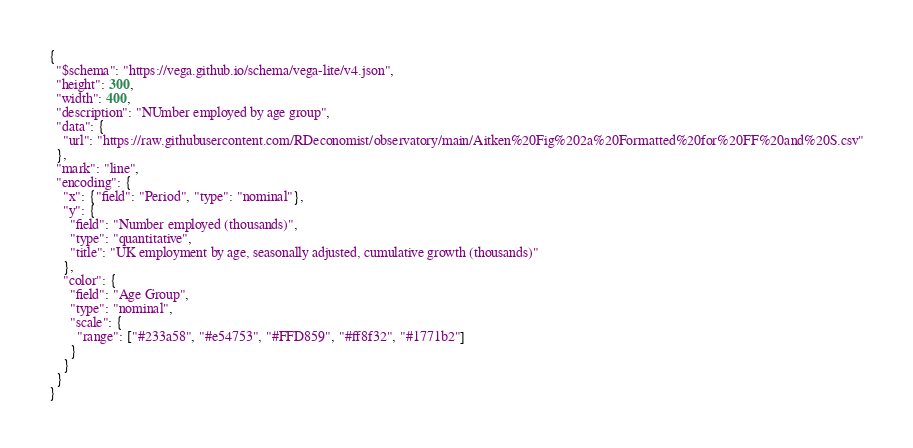<code> <loc_0><loc_0><loc_500><loc_500><_JavaScript_>{
  "$schema": "https://vega.github.io/schema/vega-lite/v4.json",
  "height": 300,
  "width": 400,
  "description": "NUmber employed by age group",
  "data": {
    "url": "https://raw.githubusercontent.com/RDeconomist/observatory/main/Aitken%20Fig%202a%20Formatted%20for%20FF%20and%20S.csv"
  },
  "mark": "line",
  "encoding": {
    "x": {"field": "Period", "type": "nominal"},
    "y": {
      "field": "Number employed (thousands)",
      "type": "quantitative",
      "title": "UK employment by age, seasonally adjusted, cumulative growth (thousands)"
    },
    "color": {
      "field": "Age Group",
      "type": "nominal",
      "scale": {
        "range": ["#233a58", "#e54753", "#FFD859", "#ff8f32", "#1771b2"]
      }
    }
  }
}</code> 